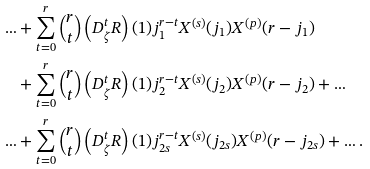<formula> <loc_0><loc_0><loc_500><loc_500>\dots & + \sum _ { t = 0 } ^ { r } \binom { r } { t } \left ( D _ { \zeta } ^ { t } R \right ) ( 1 ) j _ { 1 } ^ { r - t } X ^ { ( s ) } ( j _ { 1 } ) X ^ { ( p ) } ( r - j _ { 1 } ) \\ & + \sum _ { t = 0 } ^ { r } \binom { r } { t } \left ( D _ { \zeta } ^ { t } R \right ) ( 1 ) j _ { 2 } ^ { r - t } X ^ { ( s ) } ( j _ { 2 } ) X ^ { ( p ) } ( r - j _ { 2 } ) + \dots \\ \dots & + \sum _ { t = 0 } ^ { r } \binom { r } { t } \left ( D _ { \zeta } ^ { t } R \right ) ( 1 ) j _ { 2 s } ^ { r - t } X ^ { ( s ) } ( j _ { 2 s } ) X ^ { ( p ) } ( r - j _ { 2 s } ) + \dots .</formula> 